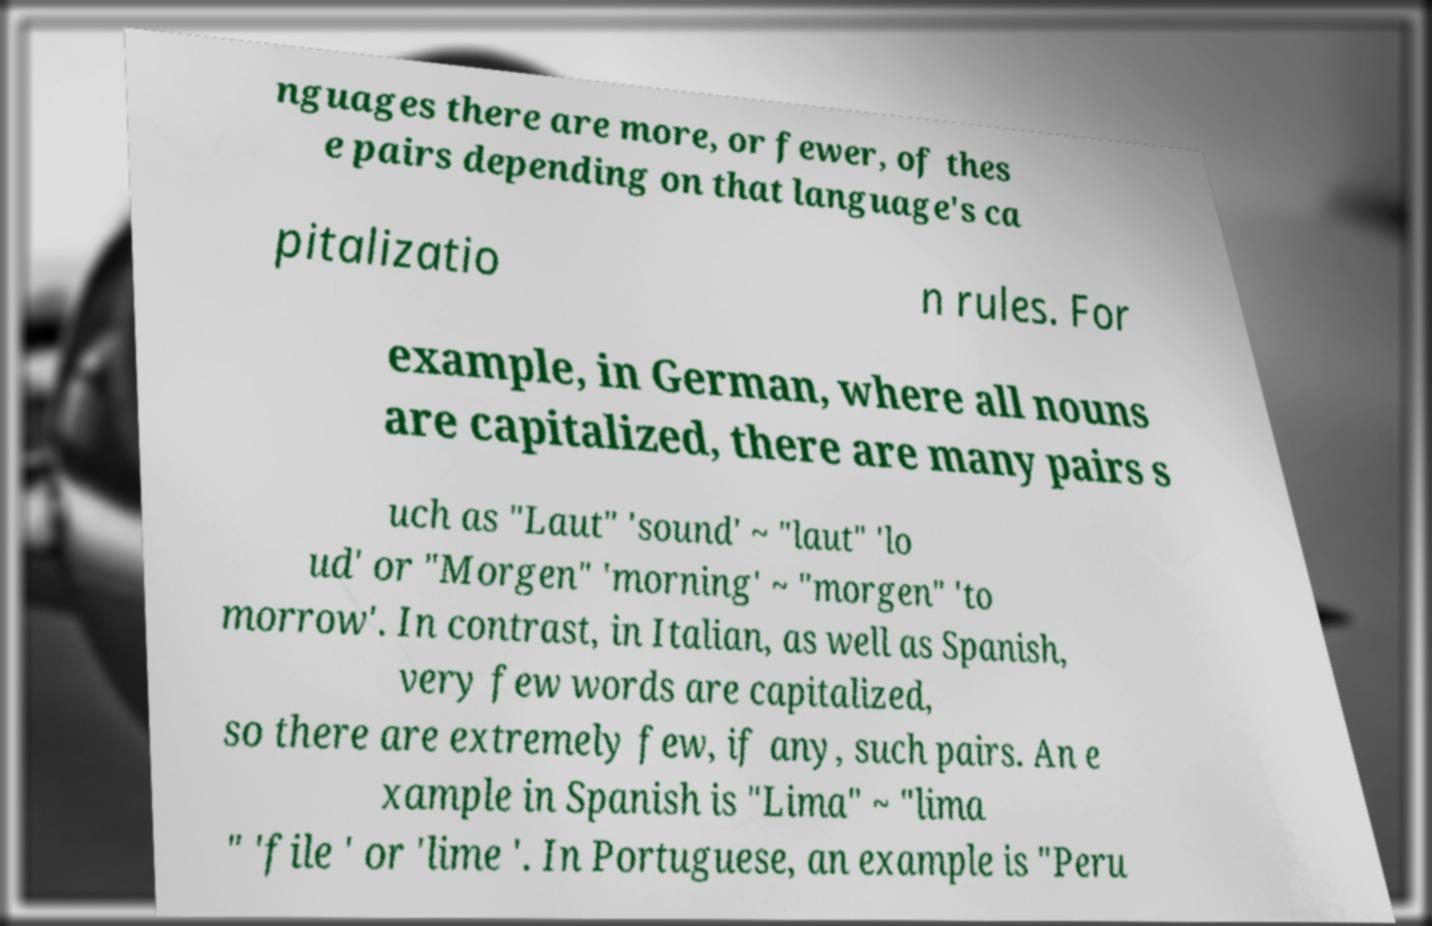Could you assist in decoding the text presented in this image and type it out clearly? nguages there are more, or fewer, of thes e pairs depending on that language's ca pitalizatio n rules. For example, in German, where all nouns are capitalized, there are many pairs s uch as "Laut" 'sound' ~ "laut" 'lo ud' or "Morgen" 'morning' ~ "morgen" 'to morrow'. In contrast, in Italian, as well as Spanish, very few words are capitalized, so there are extremely few, if any, such pairs. An e xample in Spanish is "Lima" ~ "lima " 'file ' or 'lime '. In Portuguese, an example is "Peru 